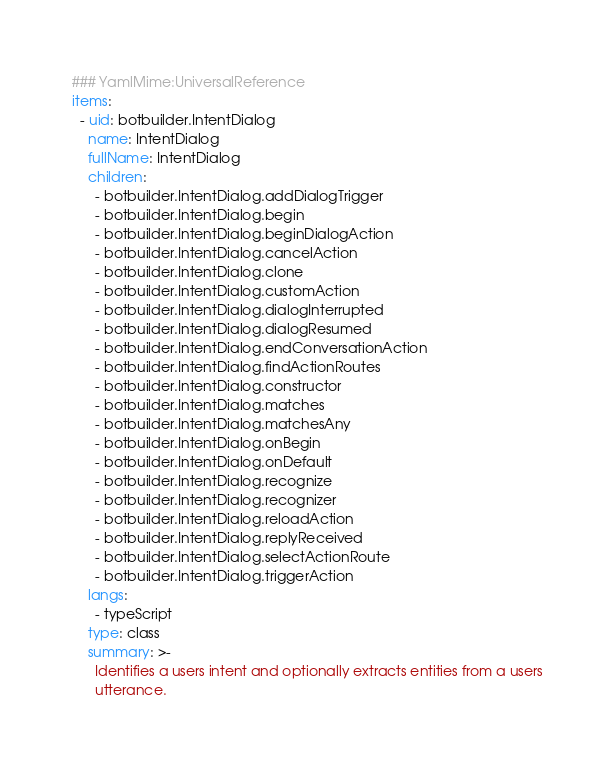Convert code to text. <code><loc_0><loc_0><loc_500><loc_500><_YAML_>### YamlMime:UniversalReference
items:
  - uid: botbuilder.IntentDialog
    name: IntentDialog
    fullName: IntentDialog
    children:
      - botbuilder.IntentDialog.addDialogTrigger
      - botbuilder.IntentDialog.begin
      - botbuilder.IntentDialog.beginDialogAction
      - botbuilder.IntentDialog.cancelAction
      - botbuilder.IntentDialog.clone
      - botbuilder.IntentDialog.customAction
      - botbuilder.IntentDialog.dialogInterrupted
      - botbuilder.IntentDialog.dialogResumed
      - botbuilder.IntentDialog.endConversationAction
      - botbuilder.IntentDialog.findActionRoutes
      - botbuilder.IntentDialog.constructor
      - botbuilder.IntentDialog.matches
      - botbuilder.IntentDialog.matchesAny
      - botbuilder.IntentDialog.onBegin
      - botbuilder.IntentDialog.onDefault
      - botbuilder.IntentDialog.recognize
      - botbuilder.IntentDialog.recognizer
      - botbuilder.IntentDialog.reloadAction
      - botbuilder.IntentDialog.replyReceived
      - botbuilder.IntentDialog.selectActionRoute
      - botbuilder.IntentDialog.triggerAction
    langs:
      - typeScript
    type: class
    summary: >-
      Identifies a users intent and optionally extracts entities from a users
      utterance.</code> 